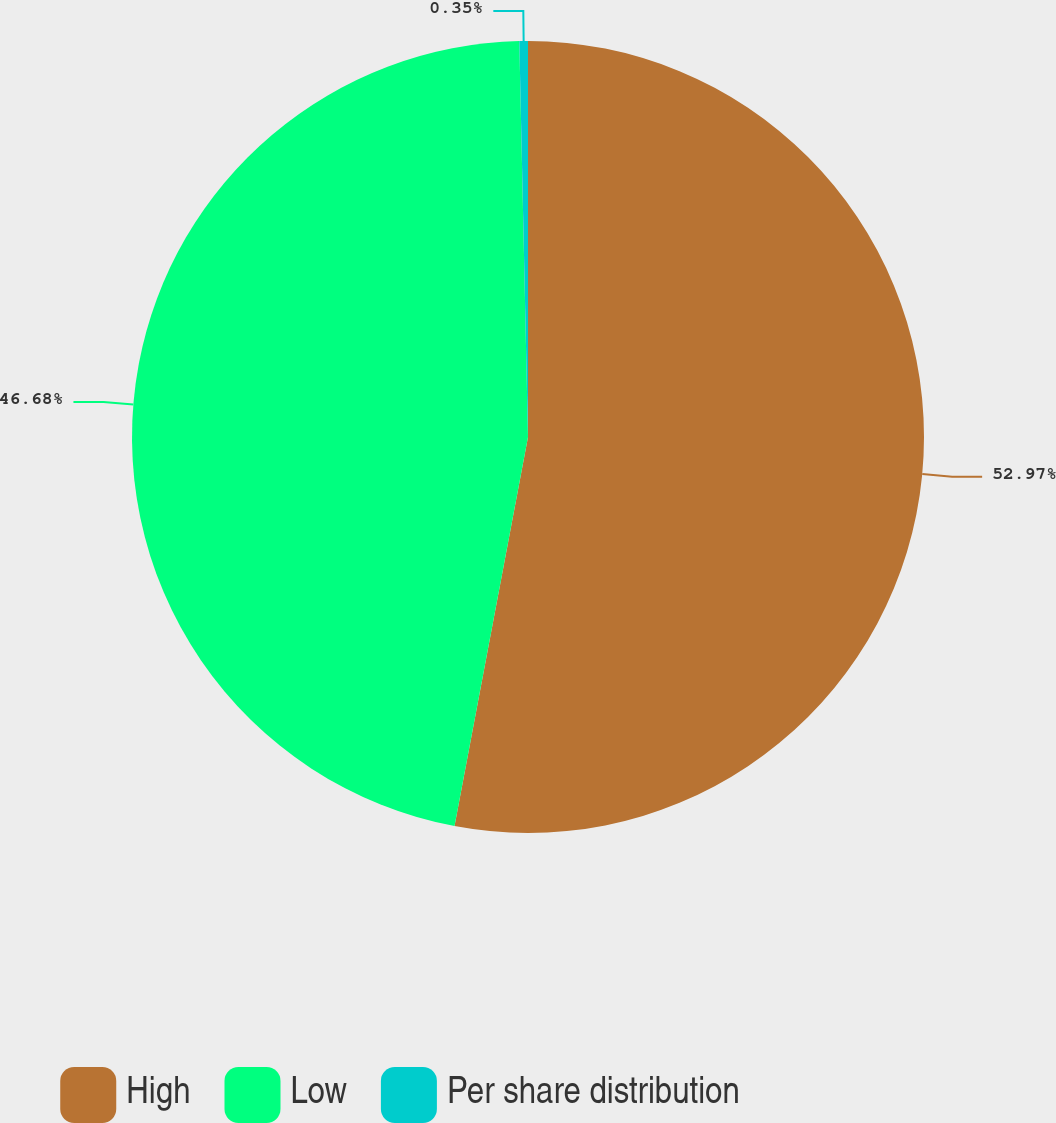Convert chart. <chart><loc_0><loc_0><loc_500><loc_500><pie_chart><fcel>High<fcel>Low<fcel>Per share distribution<nl><fcel>52.97%<fcel>46.68%<fcel>0.35%<nl></chart> 